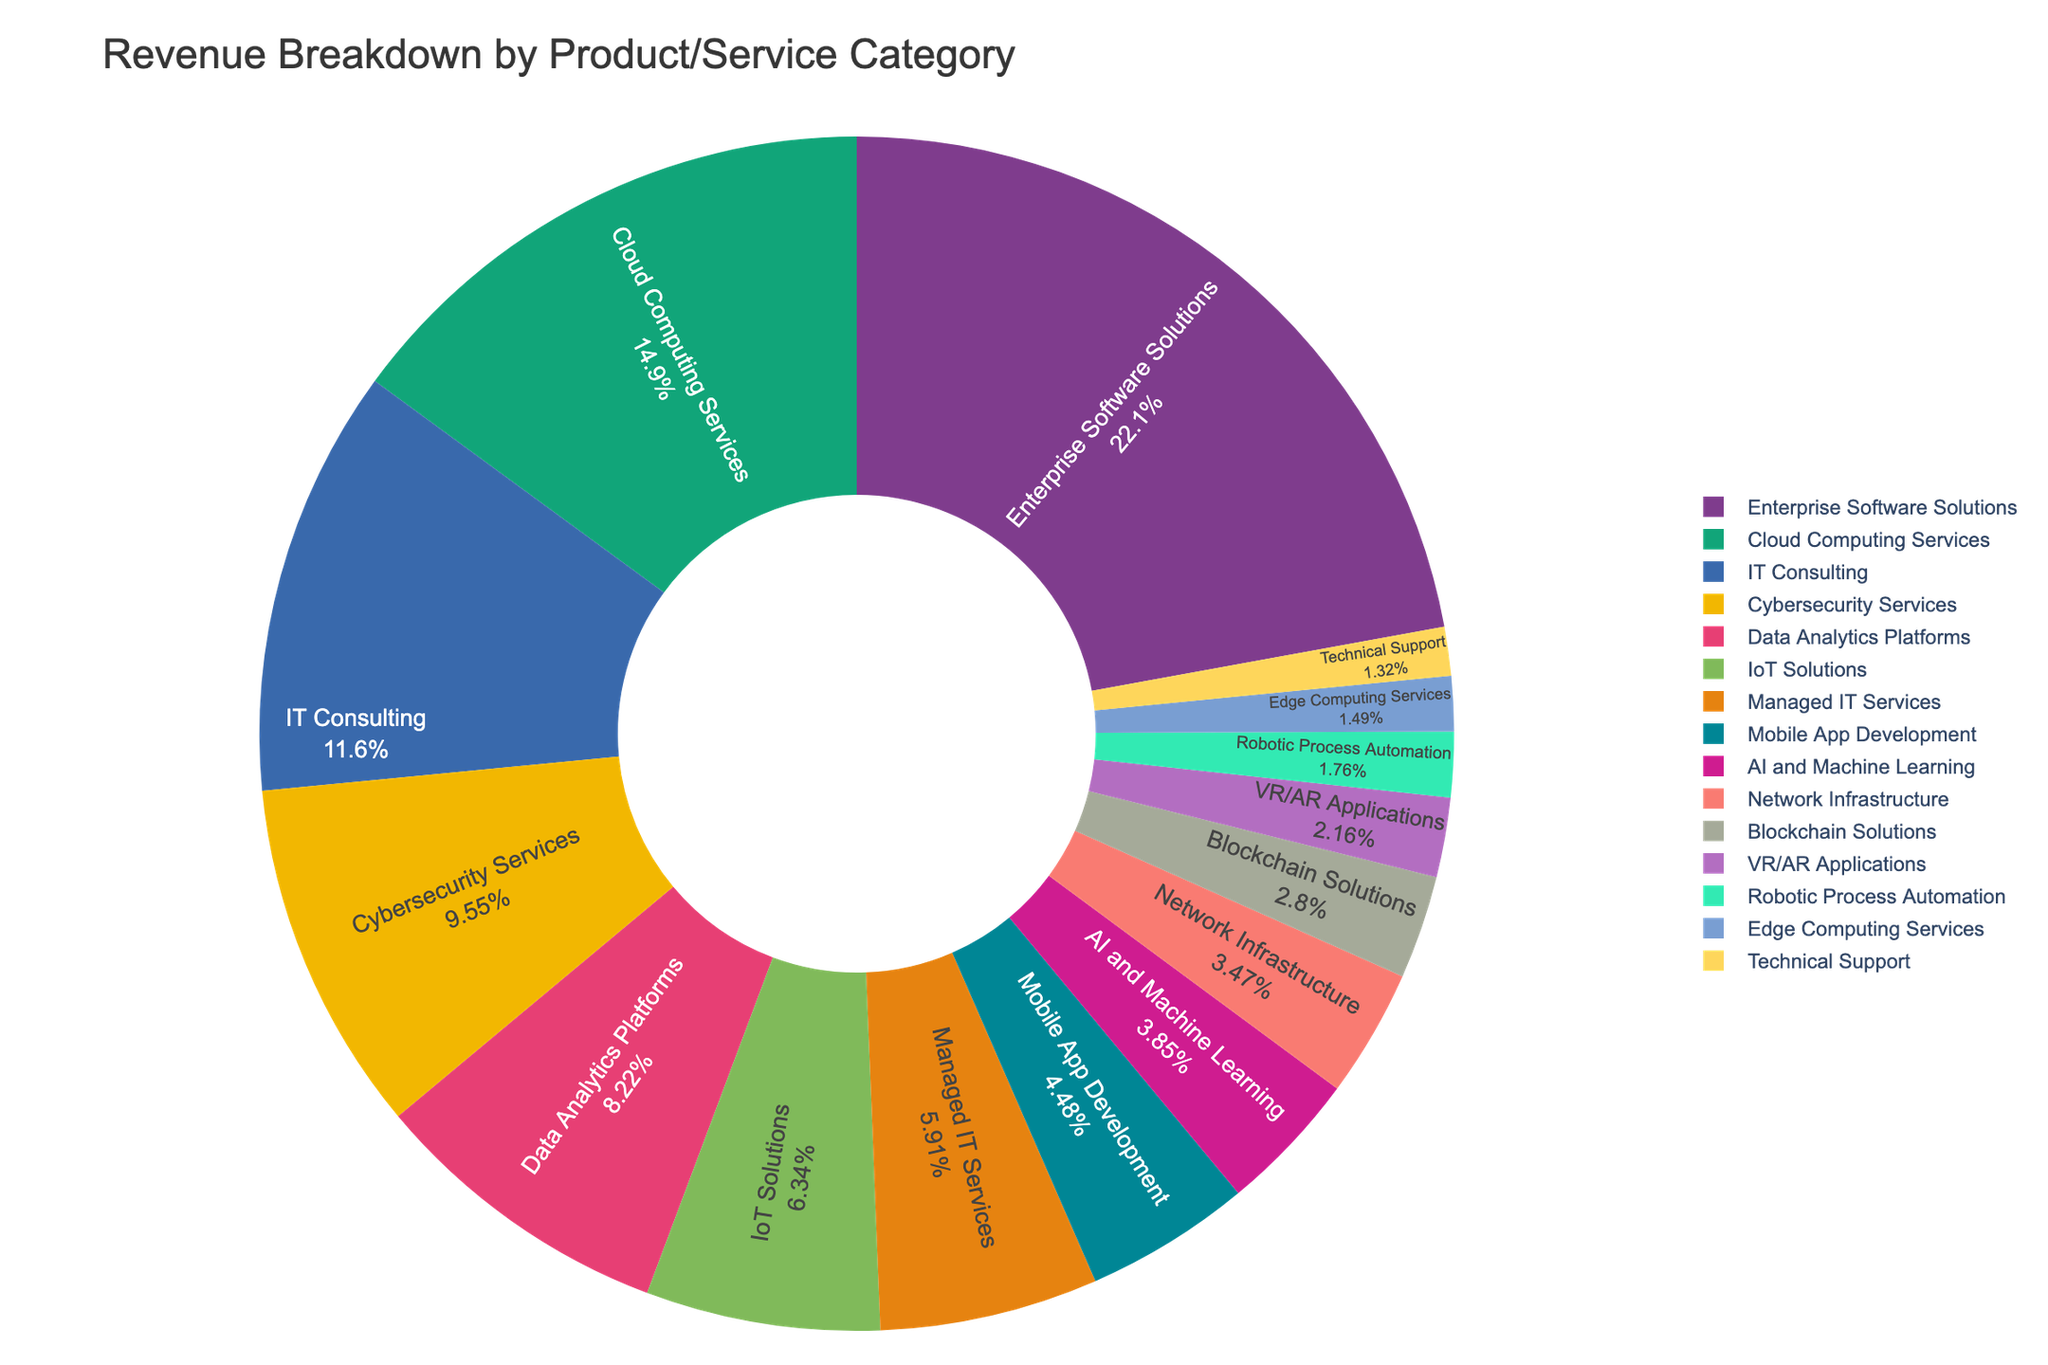Which product category generates the highest revenue? The figure shows a pie chart with segments for each product or service category. The largest segment represents the category with the highest revenue. Based on the data, Enterprise Software Solutions has the largest segment.
Answer: Enterprise Software Solutions Which product category has the smallest share of revenue? Look for the smallest segment in the pie chart which indicates the category with the least revenue. From the data, Technical Support has the smallest share.
Answer: Technical Support How much more revenue does Enterprise Software Solutions generate compared to Cloud Computing Services? Identify the revenue for both categories from the chart. Enterprise Software Solutions generates $145.6M and Cloud Computing Services generates $98.3M. Subtract the latter from the former: 145.6 - 98.3 = 47.3.
Answer: $47.3M What percentage of the total revenue is generated by IT Consulting? The pie chart includes percentage labels for each segment. Identify the segment for IT Consulting, which reads the percentage directly. The percentage is approximately 10.9%.
Answer: 10.9% How does the revenue from IoT Solutions compare to that of Managed IT Services? Compare the size of the segments corresponding to IoT Solutions and Managed IT Services. IoT Solutions generates $41.7M and Managed IT Services generates $38.9M. Since 41.7 > 38.9, IoT Solutions has higher revenue.
Answer: IoT Solutions has higher revenue What is the combined revenue of Data Analytics Platforms, AI and Machine Learning, and VR/AR Applications? Sum the revenue values of the three mentioned categories: Data Analytics Platforms ($54.1M), AI and Machine Learning ($25.3M), and VR/AR Applications ($14.2M). Calculating: 54.1 + 25.3 + 14.2 = 93.6.
Answer: $93.6M What are the three smallest revenue categories, and what is their total revenue? Identify the three smallest segments in the pie chart: Technical Support ($8.7M), Edge Computing Services ($9.8M), and Robotic Process Automation ($11.6M). Sum these values: 8.7 + 9.8 + 11.6 = 30.1.
Answer: Technical Support, Edge Computing Services, and Robotic Process Automation; $30.1M What is the difference between the revenue of Cybersecurity Services and Network Infrastructure? Identify the revenue for both categories: Cybersecurity Services ($62.8M) and Network Infrastructure ($22.8M). Subtract the latter from the former: 62.8 - 22.8 = 40.
Answer: $40M Which category is just above AI and Machine Learning in terms of revenue? Locate the segment representing AI and Machine Learning and find the next larger segment. Managed IT Services ($38.9M) is the next one above AI and Machine Learning ($25.3M).
Answer: Managed IT Services 